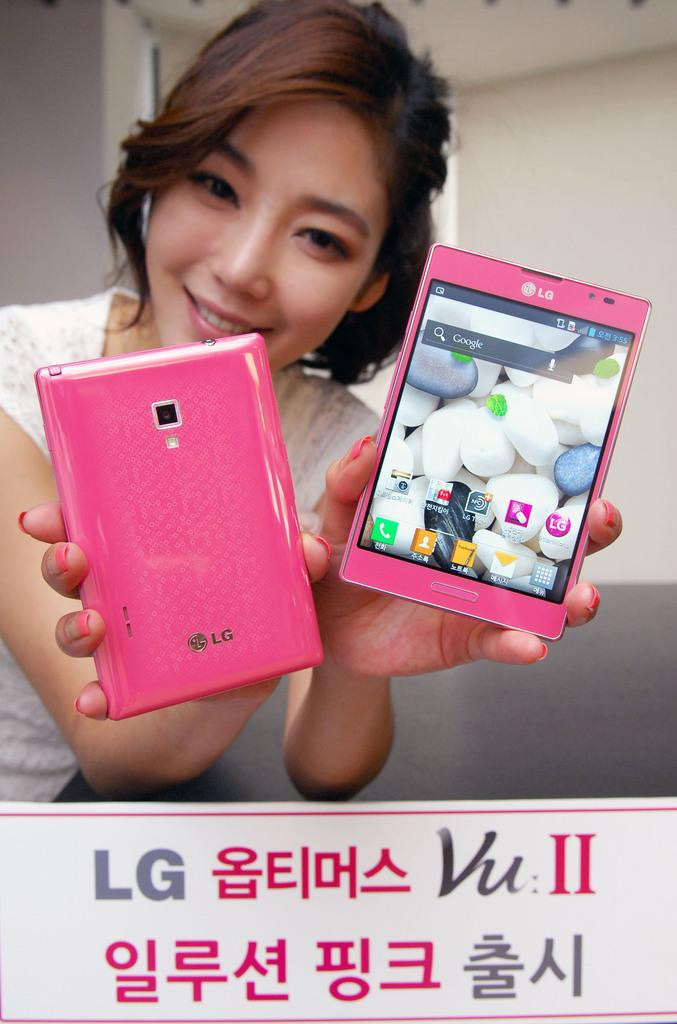<image>
Provide a brief description of the given image. A woman smiles and hold a pink LG phone in each of her hands. 